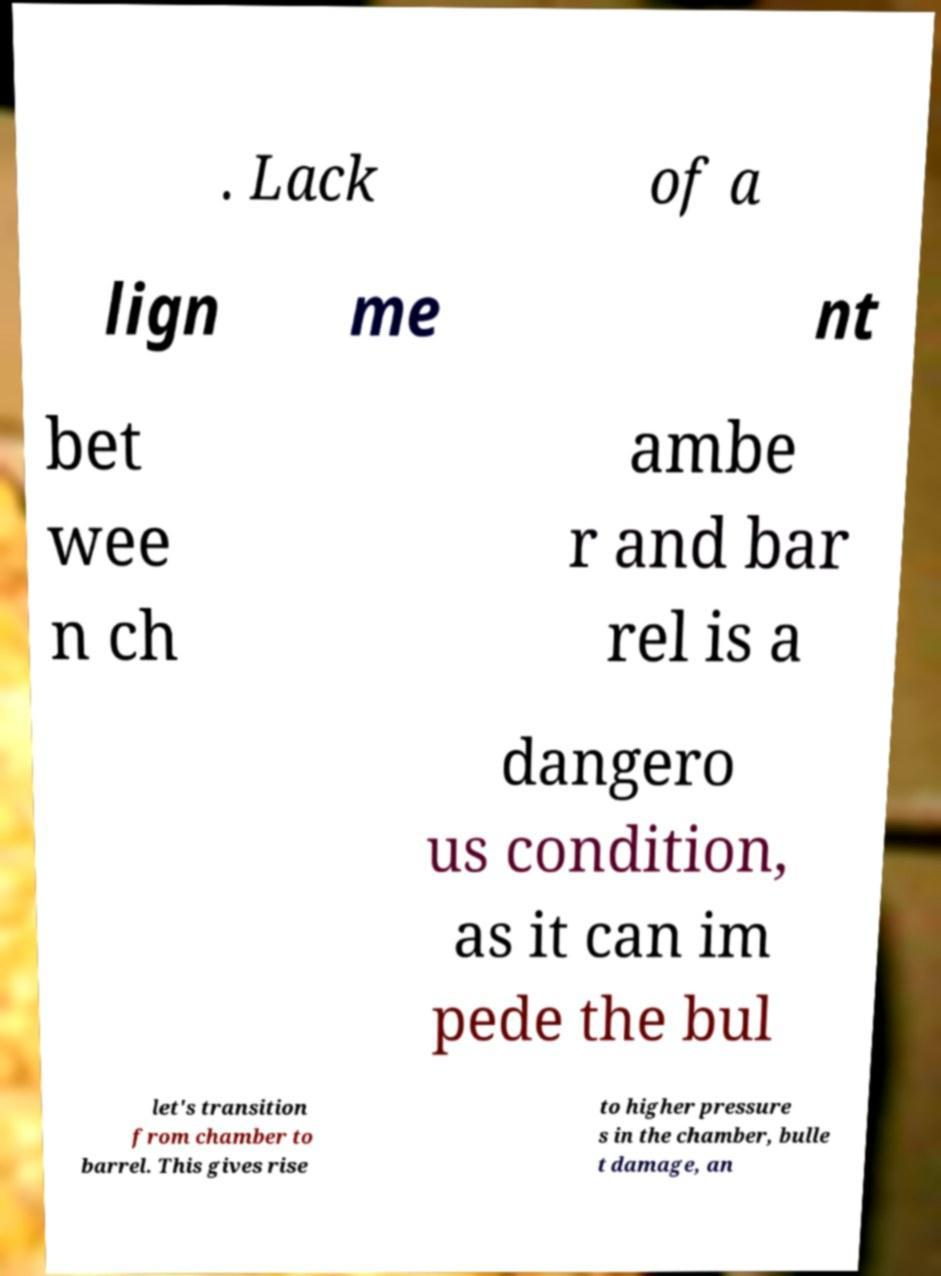Could you extract and type out the text from this image? . Lack of a lign me nt bet wee n ch ambe r and bar rel is a dangero us condition, as it can im pede the bul let's transition from chamber to barrel. This gives rise to higher pressure s in the chamber, bulle t damage, an 